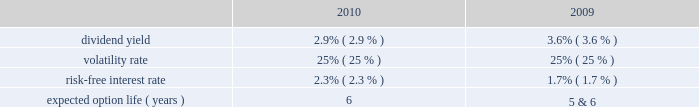Tax benefits recognized for stock-based compensation during the years ended december 31 , 2011 , 2010 and 2009 , were $ 16 million , $ 6 million and $ 5 million , respectively .
The amount of northrop grumman shares issued before the spin-off to satisfy stock-based compensation awards are recorded by northrop grumman and , accordingly , are not reflected in hii 2019s consolidated financial statements .
The company realized tax benefits during the year ended december 31 , 2011 , of $ 2 million from the exercise of stock options and $ 10 million from the issuance of stock in settlement of rpsrs and rsrs .
Unrecognized compensation expense at december 31 , 2011 there was $ 1 million of unrecognized compensation expense related to unvested stock option awards , which will be recognized over a weighted average period of 1.1 years .
In addition , at december 31 , 2011 , there was $ 19 million of unrecognized compensation expense associated with the 2011 rsrs , which will be recognized over a period of 2.2 years ; $ 10 million of unrecognized compensation expense associated with the rpsrs converted as part of the spin-off , which will be recognized over a weighted average period of one year ; and $ 18 million of unrecognized compensation expense associated with the 2011 rpsrs which will be recognized over a period of 2.0 years .
Stock options the compensation expense for the outstanding converted stock options was determined at the time of grant by northrop grumman .
There were no additional options granted during the year ended december 31 , 2011 .
The fair value of the stock option awards is expensed on a straight-line basis over the vesting period of the options .
The fair value of each of the stock option award was estimated on the date of grant using a black-scholes option pricing model based on the following assumptions : dividend yield 2014the dividend yield was based on northrop grumman 2019s historical dividend yield level .
Volatility 2014expected volatility was based on the average of the implied volatility from traded options and the historical volatility of northrop grumman 2019s stock .
Risk-free interest rate 2014the risk-free rate for periods within the contractual life of the stock option award was based on the yield curve of a zero-coupon u.s .
Treasury bond on the date the award was granted with a maturity equal to the expected term of the award .
Expected term 2014the expected term of awards granted was derived from historical experience and represents the period of time that awards granted are expected to be outstanding .
A stratification of expected terms based on employee populations ( executive and non-executive ) was considered in the analysis .
The following significant weighted-average assumptions were used to value stock options granted during the years ended december 31 , 2010 and 2009: .
The weighted-average grant date fair value of stock options granted during the years ended december 31 , 2010 and 2009 , was $ 11 and $ 7 , per share , respectively. .
What is the growth rate in the weighted-average grant date fair value of stock options from 2009 to 2010? 
Computations: ((11 - 7) / 7)
Answer: 0.57143. 